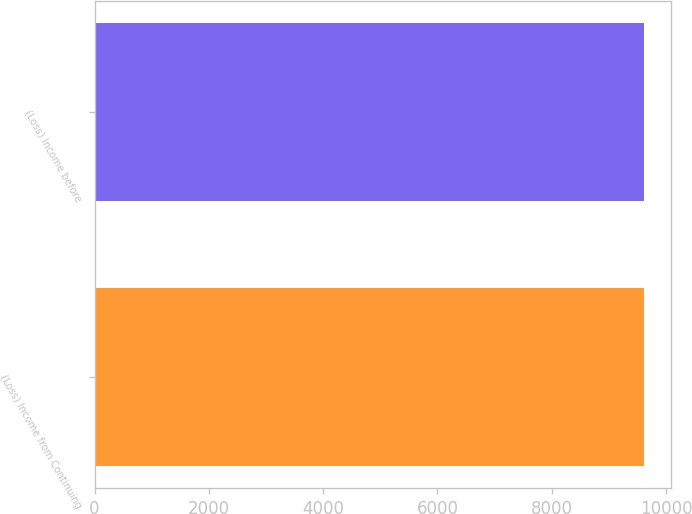Convert chart. <chart><loc_0><loc_0><loc_500><loc_500><bar_chart><fcel>(Loss) Income from Continuing<fcel>(Loss) Income before<nl><fcel>9606<fcel>9606.1<nl></chart> 